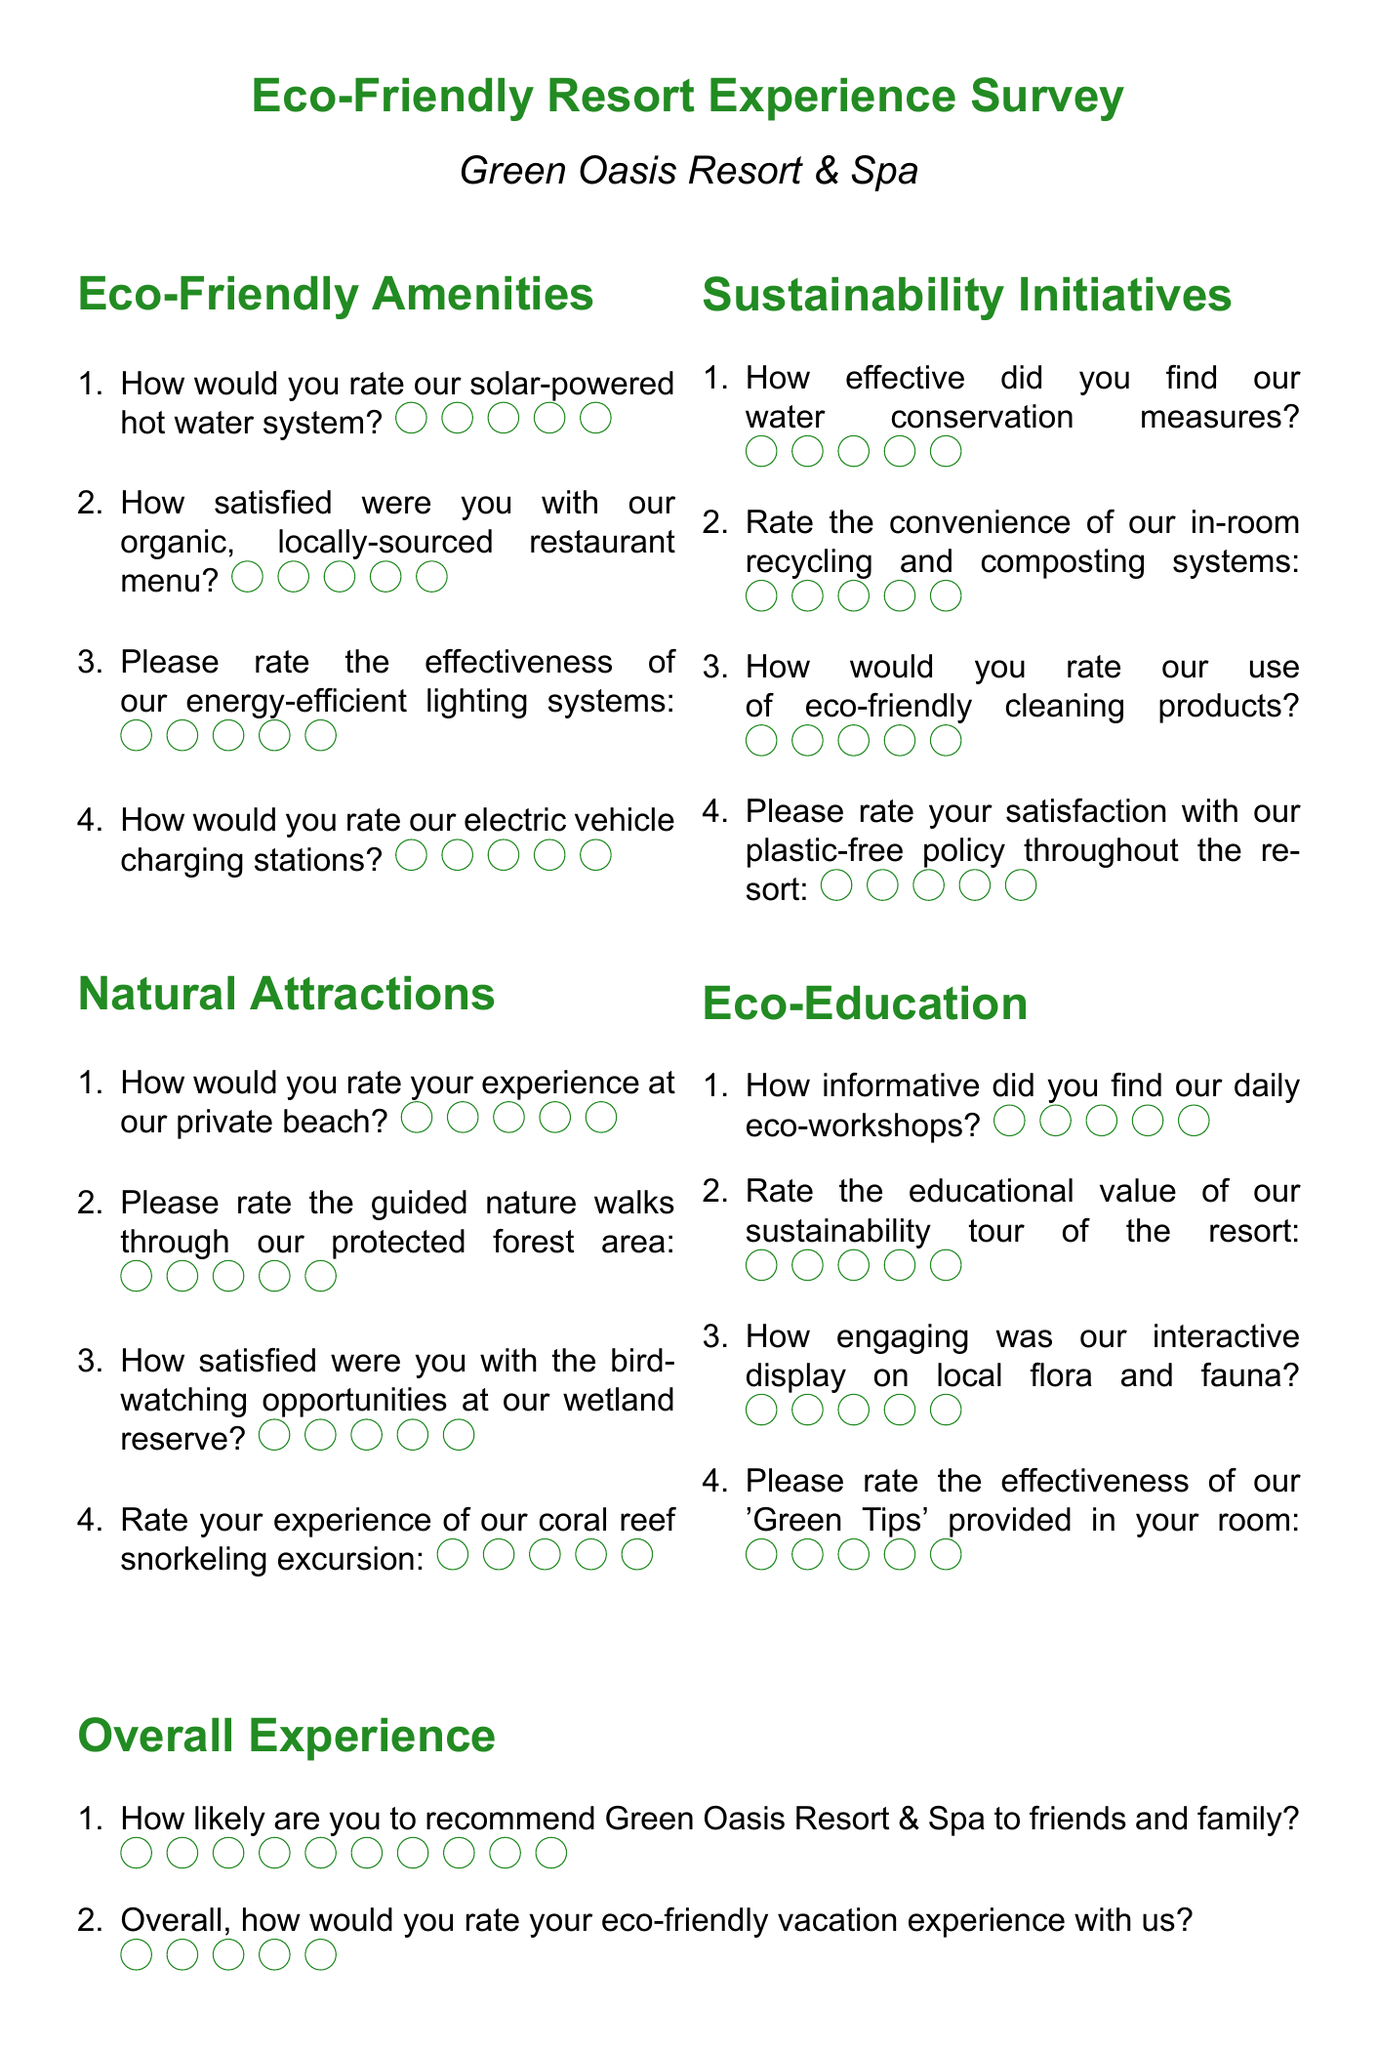How many sections are in the survey? The document contains five sections: Eco-Friendly Amenities, Natural Attractions, Sustainability Initiatives, Eco-Education, and Overall Experience.
Answer: 5 What is the maximum rating scale for the "Overall Experience" section? The "Overall Experience" section includes a question with a rating scale of 10.
Answer: 10 How would you rate your experience at the private beach? This is one of the questions found under the Natural Attractions section asking guests to provide a rating.
Answer: Rate your experience at our private beach What type of feedback is requested at the end of the Overall Experience section? A suggestion for improving eco-friendly amenities or natural attractions is asked for as open-ended feedback.
Answer: Suggestions for improving eco-friendly amenities or natural attractions How many questions are in the Eco-Friendly Amenities section? The Eco-Friendly Amenities section contains four questions.
Answer: 4 What color is used for the document title? The document title is displayed in forest green color.
Answer: Forest green How is the effectiveness of the water conservation measures rated? This evaluation is done using a standard rating system with a scale of 5.
Answer: 5 What type of activities are highlighted in the Natural Attractions section? The activities highlight experiences like private beach visits, nature walks, birdwatching, and snorkeling excursions.
Answer: Private beach, nature walks, birdwatching, snorkeling excursions What is the overall feedback format for the eco-friendly vacation experience? Guests are asked to rate their overall experience on a scale of 5.
Answer: Scale of 5 